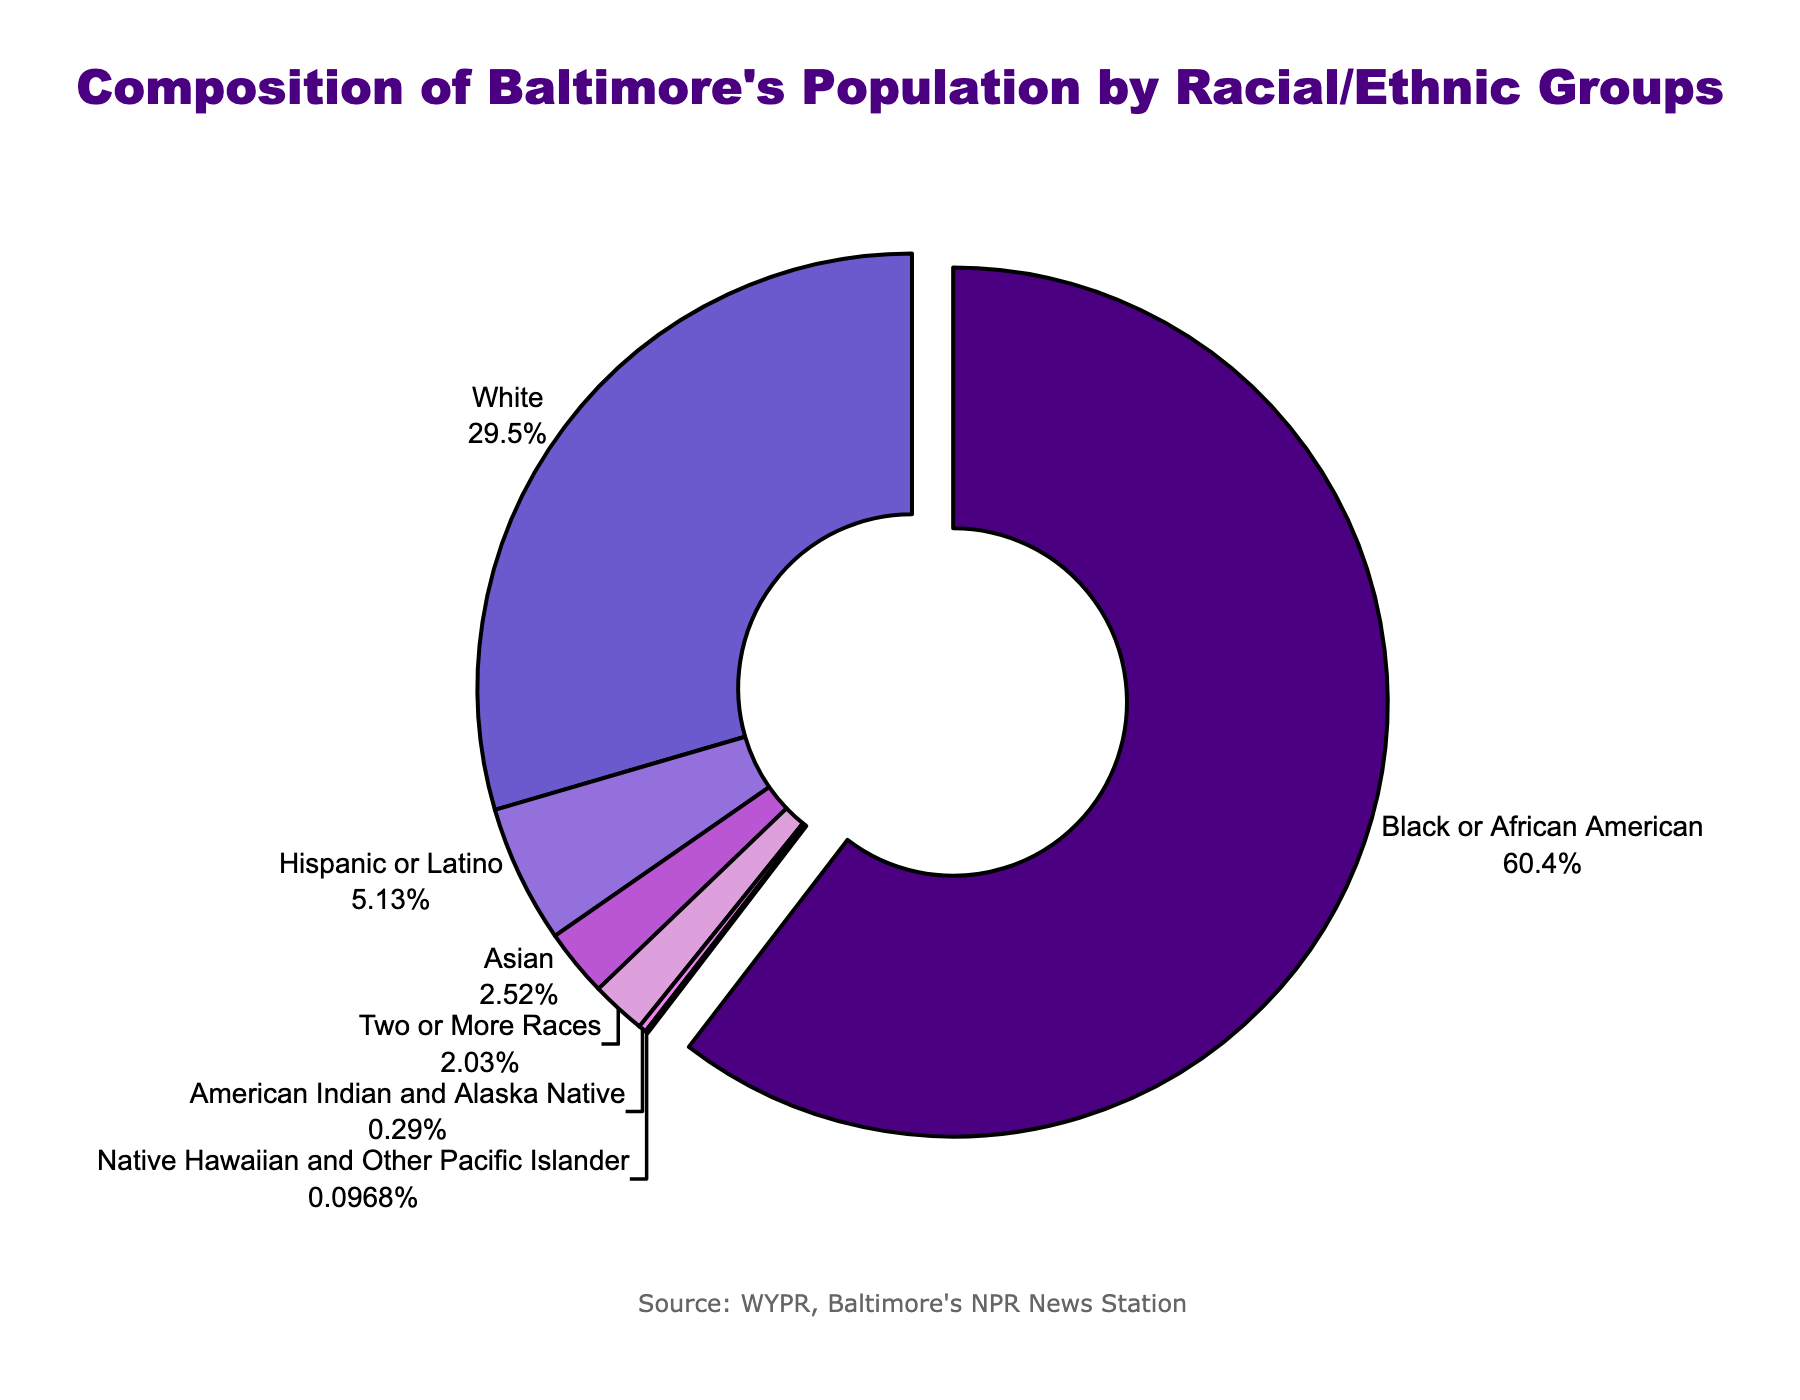What's the largest racial/ethnic group in Baltimore's population? The visual information clearly shows that the largest section of the pie chart, pulled slightly out for emphasis, is labeled "Black or African American" with a percentage of 62.4%.
Answer: Black or African American What's the combined percentage of Hispanic or Latino and Asian populations? We sum up the percentages of the Hispanic or Latino population (5.3%) and the Asian population (2.6%): 5.3 + 2.6 = 7.9%.
Answer: 7.9% Which racial/ethnic group has the smallest representation in Baltimore's population? The smallest section of the pie chart is labeled "Native Hawaiian and Other Pacific Islander" with a percentage of 0.1%.
Answer: Native Hawaiian and Other Pacific Islander Is the percentage of White population greater than the combined percentage of Asian and Two or More Races populations? The percentage of the White population is 30.5%. The combined percentage of Asian (2.6%) and Two or More Races (2.1%) is 2.6 + 2.1 = 4.7%. Since 30.5% is greater than 4.7%, the White population percentage is indeed greater.
Answer: Yes How much more is the percentage of Black or African American population than the White population? The percentage of the Black or African American population is 62.4% and the White population is 30.5%. The difference is 62.4 - 30.5 = 31.9%.
Answer: 31.9% Which group is represented by the purple color? Observing the visual information, the section representing the Asian group is colored purple.
Answer: Asian What is the combined percentage for the bottom three smallest racial/ethnic groups in the pie chart? The three smallest groups are American Indian and Alaska Native (0.3%), Native Hawaiian and Other Pacific Islander (0.1%), and Two or More Races (2.1%). Adding them up: 0.3 + 0.1 + 2.1 = 2.5%.
Answer: 2.5% Which group occupies more space in the pie chart – Hispanic or Latino or Two or More Races? The Hispanic or Latino group is 5.3% while the Two or More Races group is 2.1%. Since 5.3% is greater than 2.1%, Hispanic or Latino occupies more space.
Answer: Hispanic or Latino 